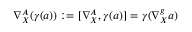<formula> <loc_0><loc_0><loc_500><loc_500>\nabla _ { X } ^ { A } ( \gamma ( a ) ) \colon = [ \nabla _ { X } ^ { A } , \gamma ( a ) ] = \gamma ( \nabla _ { X } ^ { g } a )</formula> 